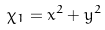<formula> <loc_0><loc_0><loc_500><loc_500>\chi _ { 1 } = x ^ { 2 } + y ^ { 2 }</formula> 